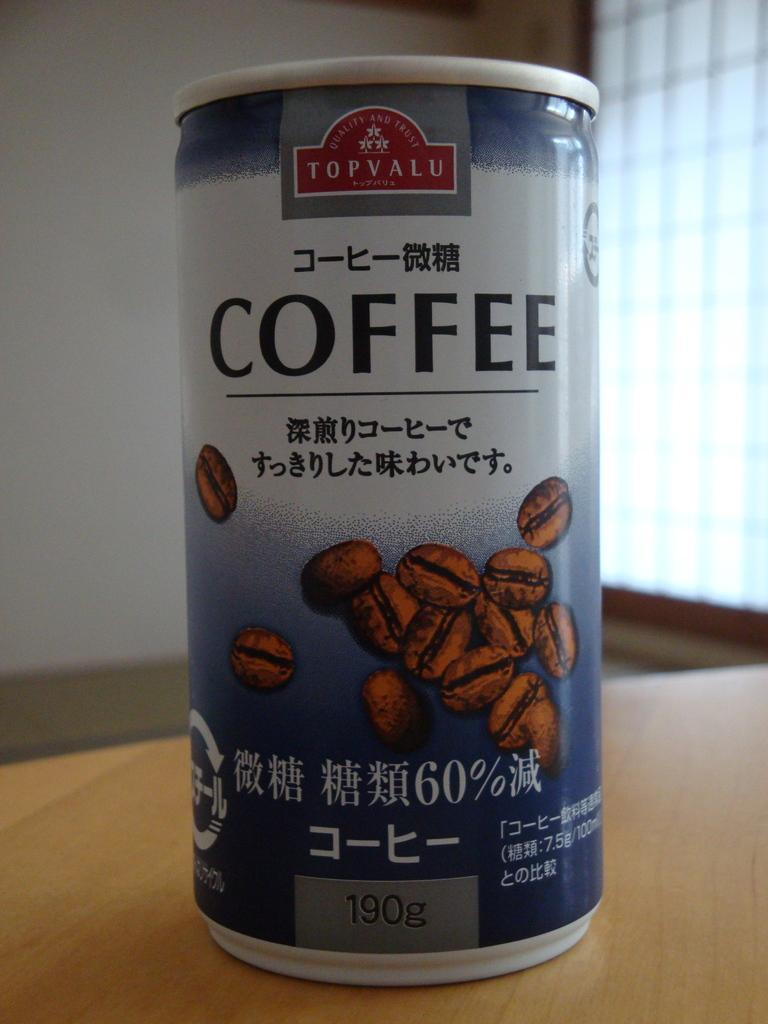<image>
Present a compact description of the photo's key features. a coffee that is on a table with many beans on it 